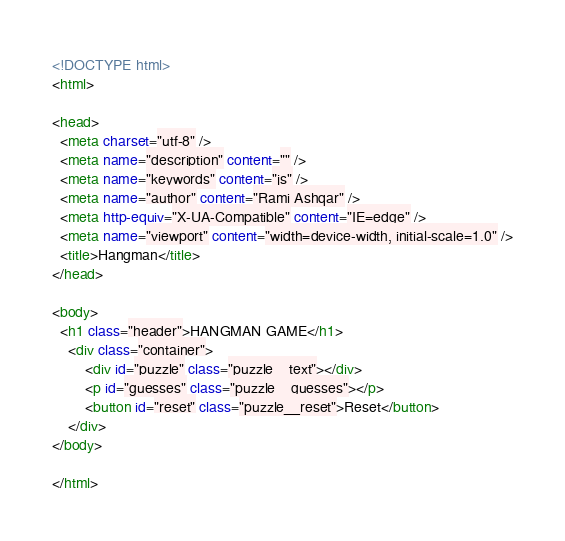<code> <loc_0><loc_0><loc_500><loc_500><_HTML_><!DOCTYPE html>
<html>

<head>
  <meta charset="utf-8" />
  <meta name="description" content="" />
  <meta name="keywords" content="js" />
  <meta name="author" content="Rami Ashqar" />
  <meta http-equiv="X-UA-Compatible" content="IE=edge" />
  <meta name="viewport" content="width=device-width, initial-scale=1.0" />
  <title>Hangman</title>
</head>

<body>
  <h1 class="header">HANGMAN GAME</h1>
    <div class="container">
        <div id="puzzle" class="puzzle__text"></div>
        <p id="guesses" class="puzzle__guesses"></p>
        <button id="reset" class="puzzle__reset">Reset</button>
    </div>
</body>

</html></code> 